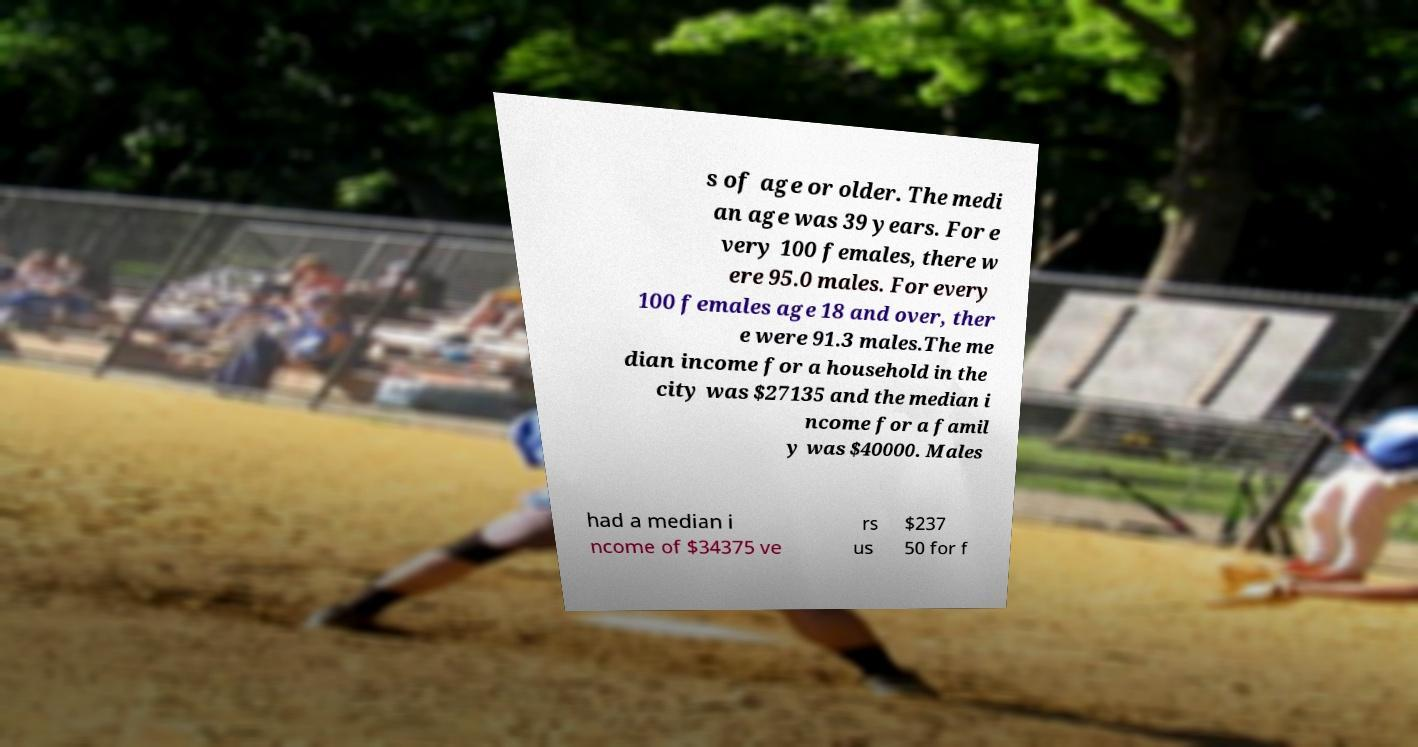Could you assist in decoding the text presented in this image and type it out clearly? s of age or older. The medi an age was 39 years. For e very 100 females, there w ere 95.0 males. For every 100 females age 18 and over, ther e were 91.3 males.The me dian income for a household in the city was $27135 and the median i ncome for a famil y was $40000. Males had a median i ncome of $34375 ve rs us $237 50 for f 